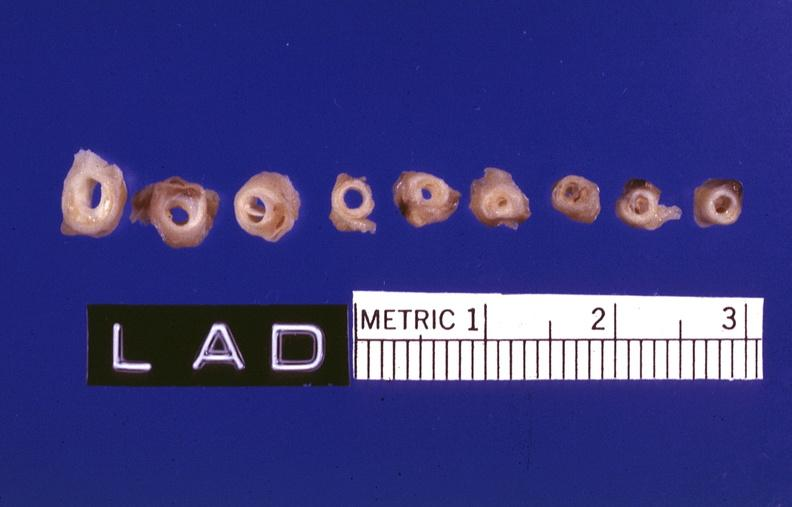s natural color present?
Answer the question using a single word or phrase. No 